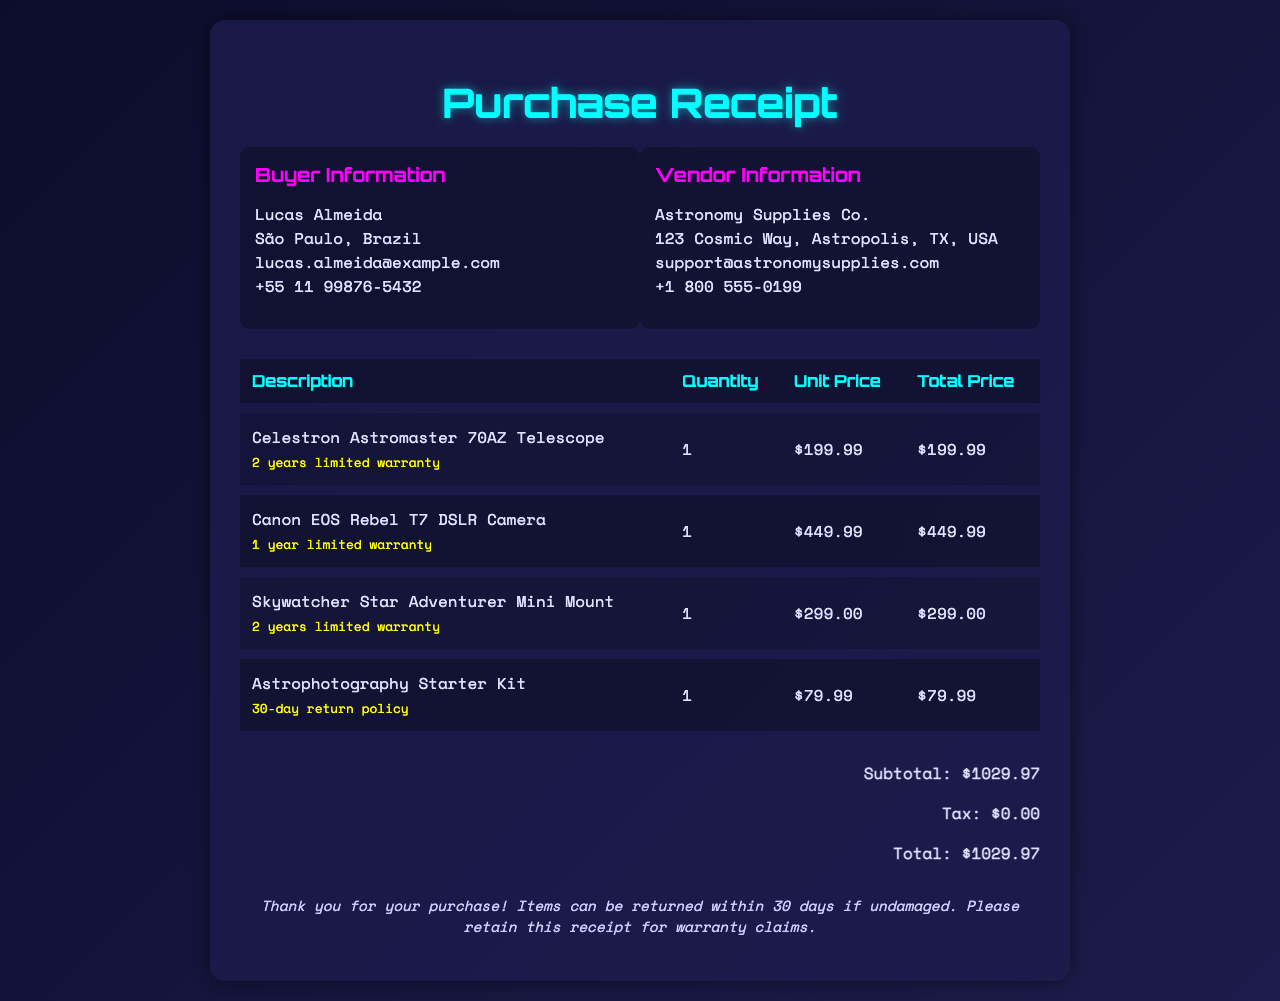What is the name of the buyer? The buyer's name is located at the top of the document under "Buyer Information."
Answer: Lucas Almeida What is the total amount of the purchase? The total amount is displayed in the "totals" section of the invoice.
Answer: $1029.97 How many years is the warranty for the Celestron Astromaster 70AZ Telescope? The warranty information for the telescope is noted in the item description on the invoice.
Answer: 2 years What item has a 30-day return policy? This item is specified in the item description on the invoice.
Answer: Astrophotography Starter Kit What is the vendor's support email address? The vendor's contact information is found under "Vendor Information."
Answer: support@astronomysupplies.com How many items were purchased in total? The total number of items can be determined by summing the quantities in the invoice's item table.
Answer: 4 What is the unit price of the Canon EOS Rebel T7 DSLR Camera? The price per unit is indicated in the item's respective column in the invoice's item table.
Answer: $449.99 What type of document is this? This document serves a specific purpose in transactions and is identifiable by its structure and content.
Answer: Invoice What is the city of the vendor? The city of the vendor is displayed in the address under "Vendor Information."
Answer: Astropolis 